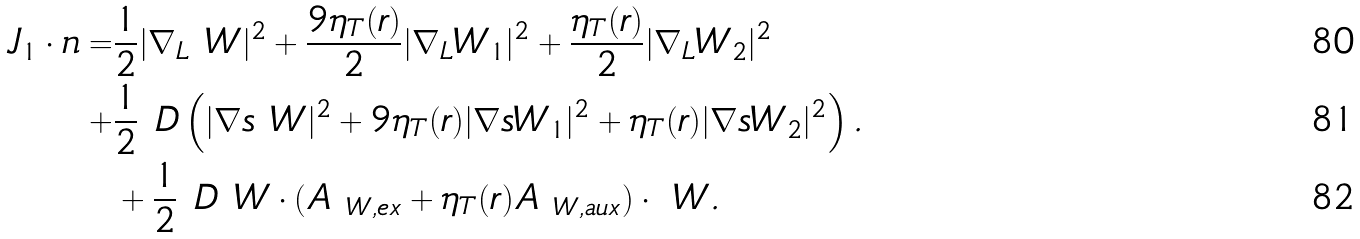Convert formula to latex. <formula><loc_0><loc_0><loc_500><loc_500>J _ { 1 } \cdot n = & \frac { 1 } { 2 } | \nabla _ { L } \ W | ^ { 2 } + \frac { 9 \eta _ { T } ( r ) } { 2 } | \nabla _ { L } W _ { 1 } | ^ { 2 } + \frac { \eta _ { T } ( r ) } { 2 } | \nabla _ { L } W _ { 2 } | ^ { 2 } \\ + & \frac { 1 } { 2 } \ D \left ( | \nabla s \ W | ^ { 2 } + { 9 \eta _ { T } ( r ) } | \nabla s W _ { 1 } | ^ { 2 } + { \eta _ { T } ( r ) } | \nabla s W _ { 2 } | ^ { 2 } \right ) . \\ & + \frac { 1 } { 2 } \ D \ W \cdot ( A _ { \ W , e x } + \eta _ { T } ( r ) A _ { \ W , a u x } ) \cdot \ W .</formula> 